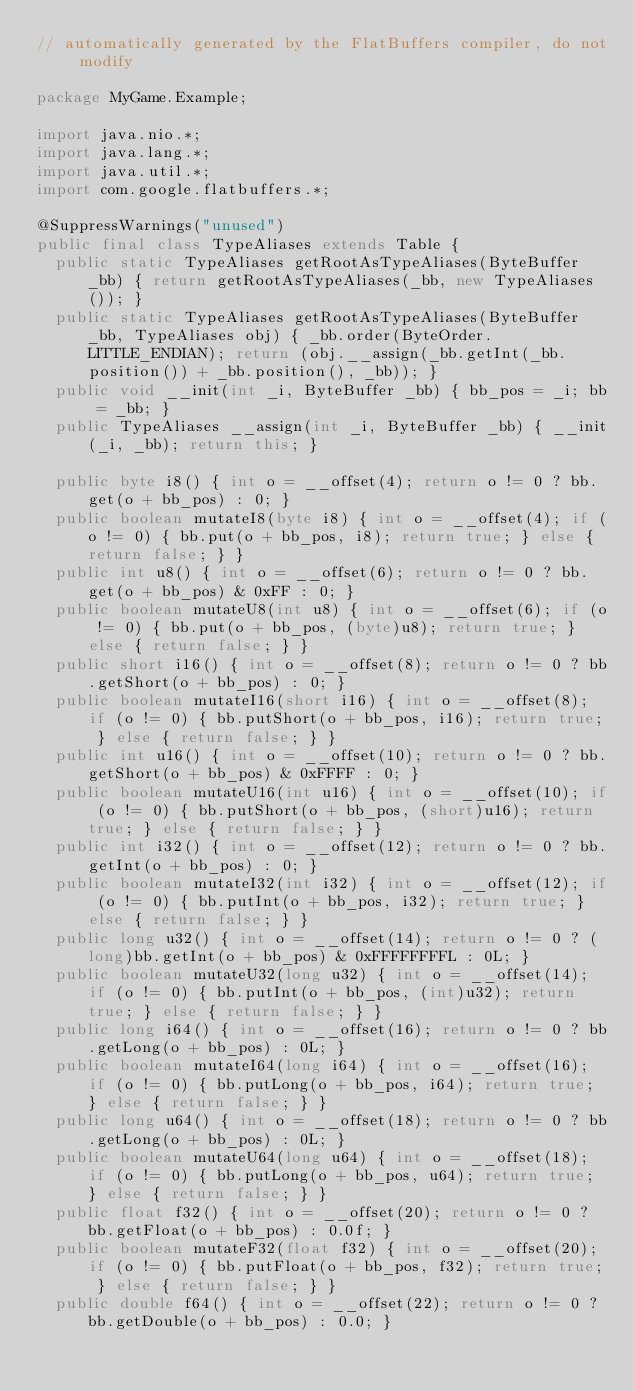<code> <loc_0><loc_0><loc_500><loc_500><_Java_>// automatically generated by the FlatBuffers compiler, do not modify

package MyGame.Example;

import java.nio.*;
import java.lang.*;
import java.util.*;
import com.google.flatbuffers.*;

@SuppressWarnings("unused")
public final class TypeAliases extends Table {
  public static TypeAliases getRootAsTypeAliases(ByteBuffer _bb) { return getRootAsTypeAliases(_bb, new TypeAliases()); }
  public static TypeAliases getRootAsTypeAliases(ByteBuffer _bb, TypeAliases obj) { _bb.order(ByteOrder.LITTLE_ENDIAN); return (obj.__assign(_bb.getInt(_bb.position()) + _bb.position(), _bb)); }
  public void __init(int _i, ByteBuffer _bb) { bb_pos = _i; bb = _bb; }
  public TypeAliases __assign(int _i, ByteBuffer _bb) { __init(_i, _bb); return this; }

  public byte i8() { int o = __offset(4); return o != 0 ? bb.get(o + bb_pos) : 0; }
  public boolean mutateI8(byte i8) { int o = __offset(4); if (o != 0) { bb.put(o + bb_pos, i8); return true; } else { return false; } }
  public int u8() { int o = __offset(6); return o != 0 ? bb.get(o + bb_pos) & 0xFF : 0; }
  public boolean mutateU8(int u8) { int o = __offset(6); if (o != 0) { bb.put(o + bb_pos, (byte)u8); return true; } else { return false; } }
  public short i16() { int o = __offset(8); return o != 0 ? bb.getShort(o + bb_pos) : 0; }
  public boolean mutateI16(short i16) { int o = __offset(8); if (o != 0) { bb.putShort(o + bb_pos, i16); return true; } else { return false; } }
  public int u16() { int o = __offset(10); return o != 0 ? bb.getShort(o + bb_pos) & 0xFFFF : 0; }
  public boolean mutateU16(int u16) { int o = __offset(10); if (o != 0) { bb.putShort(o + bb_pos, (short)u16); return true; } else { return false; } }
  public int i32() { int o = __offset(12); return o != 0 ? bb.getInt(o + bb_pos) : 0; }
  public boolean mutateI32(int i32) { int o = __offset(12); if (o != 0) { bb.putInt(o + bb_pos, i32); return true; } else { return false; } }
  public long u32() { int o = __offset(14); return o != 0 ? (long)bb.getInt(o + bb_pos) & 0xFFFFFFFFL : 0L; }
  public boolean mutateU32(long u32) { int o = __offset(14); if (o != 0) { bb.putInt(o + bb_pos, (int)u32); return true; } else { return false; } }
  public long i64() { int o = __offset(16); return o != 0 ? bb.getLong(o + bb_pos) : 0L; }
  public boolean mutateI64(long i64) { int o = __offset(16); if (o != 0) { bb.putLong(o + bb_pos, i64); return true; } else { return false; } }
  public long u64() { int o = __offset(18); return o != 0 ? bb.getLong(o + bb_pos) : 0L; }
  public boolean mutateU64(long u64) { int o = __offset(18); if (o != 0) { bb.putLong(o + bb_pos, u64); return true; } else { return false; } }
  public float f32() { int o = __offset(20); return o != 0 ? bb.getFloat(o + bb_pos) : 0.0f; }
  public boolean mutateF32(float f32) { int o = __offset(20); if (o != 0) { bb.putFloat(o + bb_pos, f32); return true; } else { return false; } }
  public double f64() { int o = __offset(22); return o != 0 ? bb.getDouble(o + bb_pos) : 0.0; }</code> 